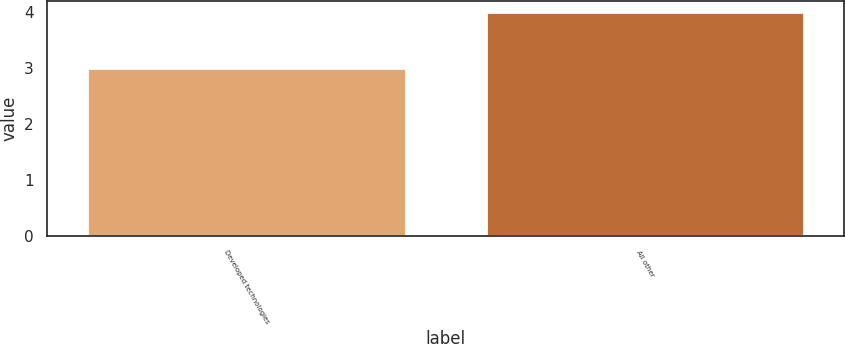Convert chart. <chart><loc_0><loc_0><loc_500><loc_500><bar_chart><fcel>Developed technologies<fcel>All other<nl><fcel>3<fcel>4<nl></chart> 